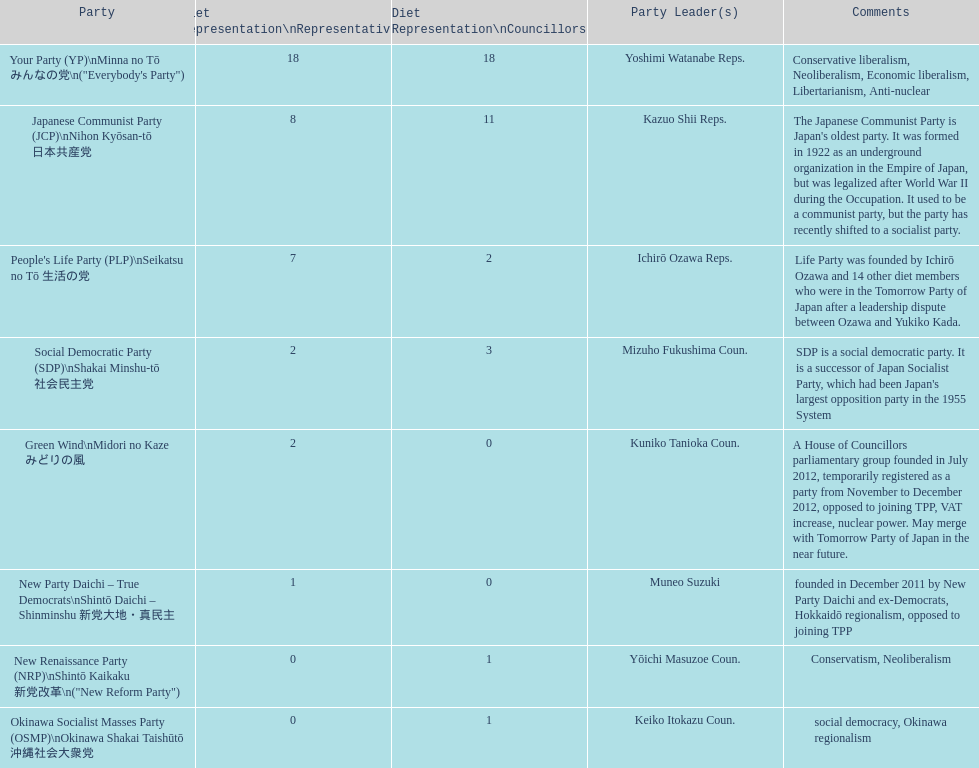What is the greatest number of party leaders the people's life party can have? 1. 